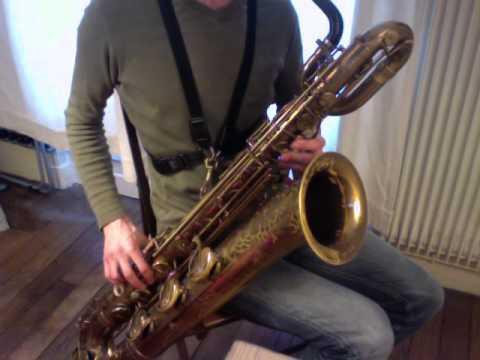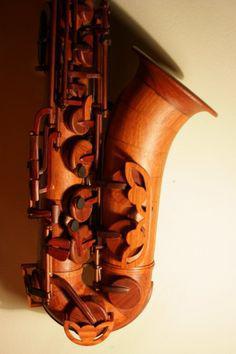The first image is the image on the left, the second image is the image on the right. For the images shown, is this caption "At least one image contains multiple saxophones." true? Answer yes or no. No. 